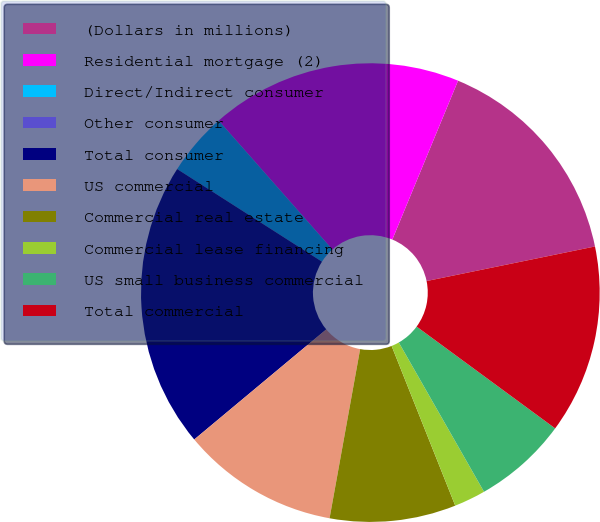<chart> <loc_0><loc_0><loc_500><loc_500><pie_chart><fcel>(Dollars in millions)<fcel>Residential mortgage (2)<fcel>Direct/Indirect consumer<fcel>Other consumer<fcel>Total consumer<fcel>US commercial<fcel>Commercial real estate<fcel>Commercial lease financing<fcel>US small business commercial<fcel>Total commercial<nl><fcel>15.53%<fcel>17.75%<fcel>4.44%<fcel>0.0%<fcel>20.12%<fcel>11.09%<fcel>8.88%<fcel>2.22%<fcel>6.66%<fcel>13.31%<nl></chart> 